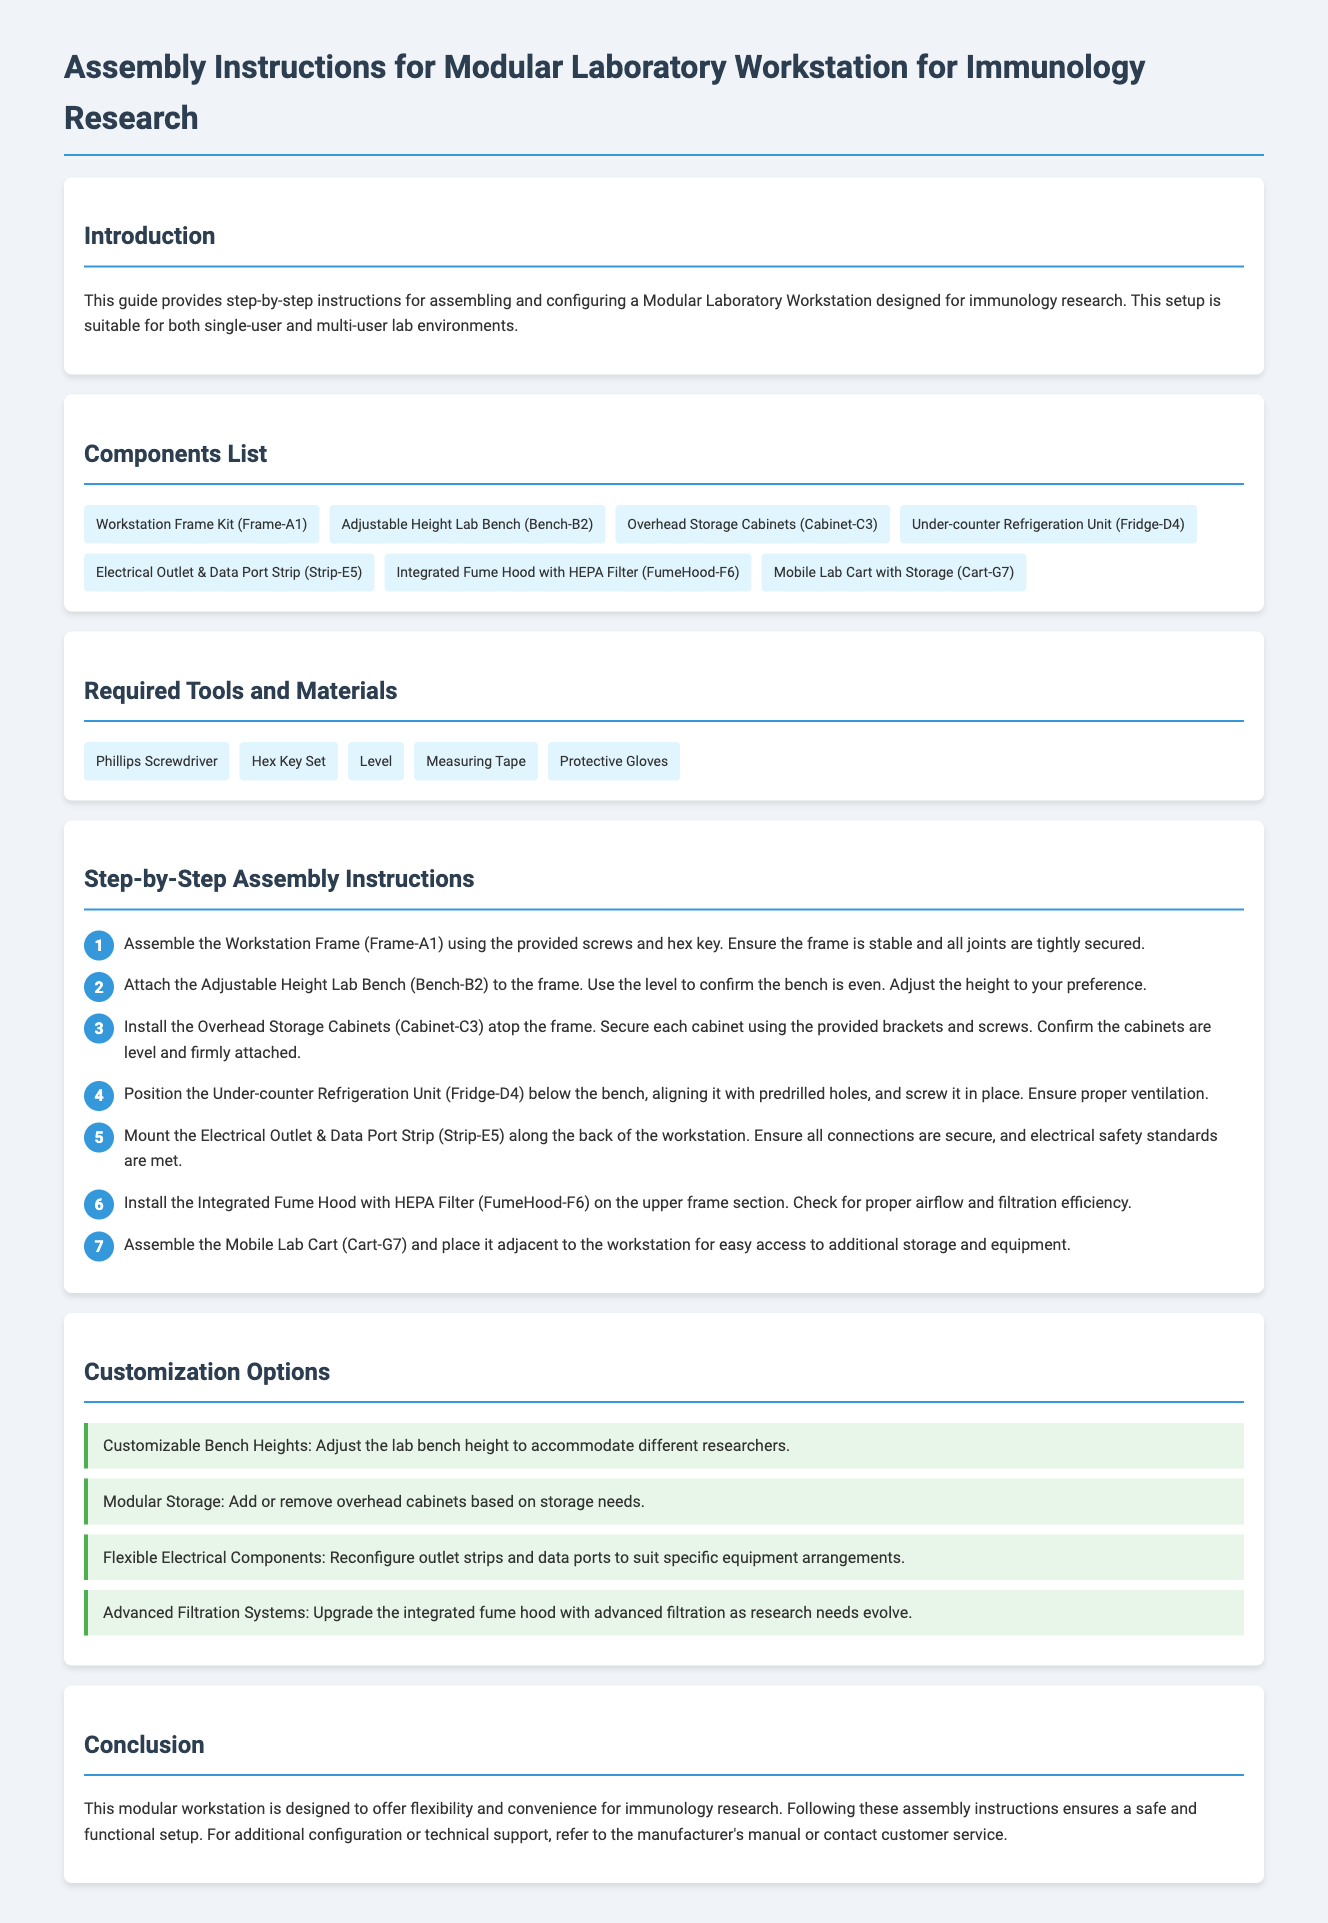what is the title of the document? The title of the document is specified in the header section of the HTML.
Answer: Assembly Instructions for Modular Laboratory Workstation for Immunology Research how many components are listed in the Components List? The document provides a total of seven items in the Components List section.
Answer: 7 which tool is used to confirm the workstation bench is even? The document mentions the specific tool used for confirming evenness during assembly.
Answer: Level what customization option allows adjusting lab bench height? This customization option enhances usability for different researchers and is mentioned in the Customization Options section.
Answer: Customizable Bench Heights what is the purpose of the Integrated Fume Hood with HEPA Filter? The document describes its function in relation to the workstation setup.
Answer: Proper airflow and filtration efficiency which component is installed under the bench? This specific component is outlined in the step-by-step assembly instructions.
Answer: Under-counter Refrigeration Unit how many steps are included in the step-by-step assembly instructions? The document counts the total number of individual assembly steps.
Answer: 7 what material is required for protection during assembly? The document lists specific items needed for safety during the assembly process.
Answer: Protective Gloves what type of workstation configuration is the document aimed at? The document indicates the suitability of the workstation type in different lab environments.
Answer: Single-user and multi-user lab environments 